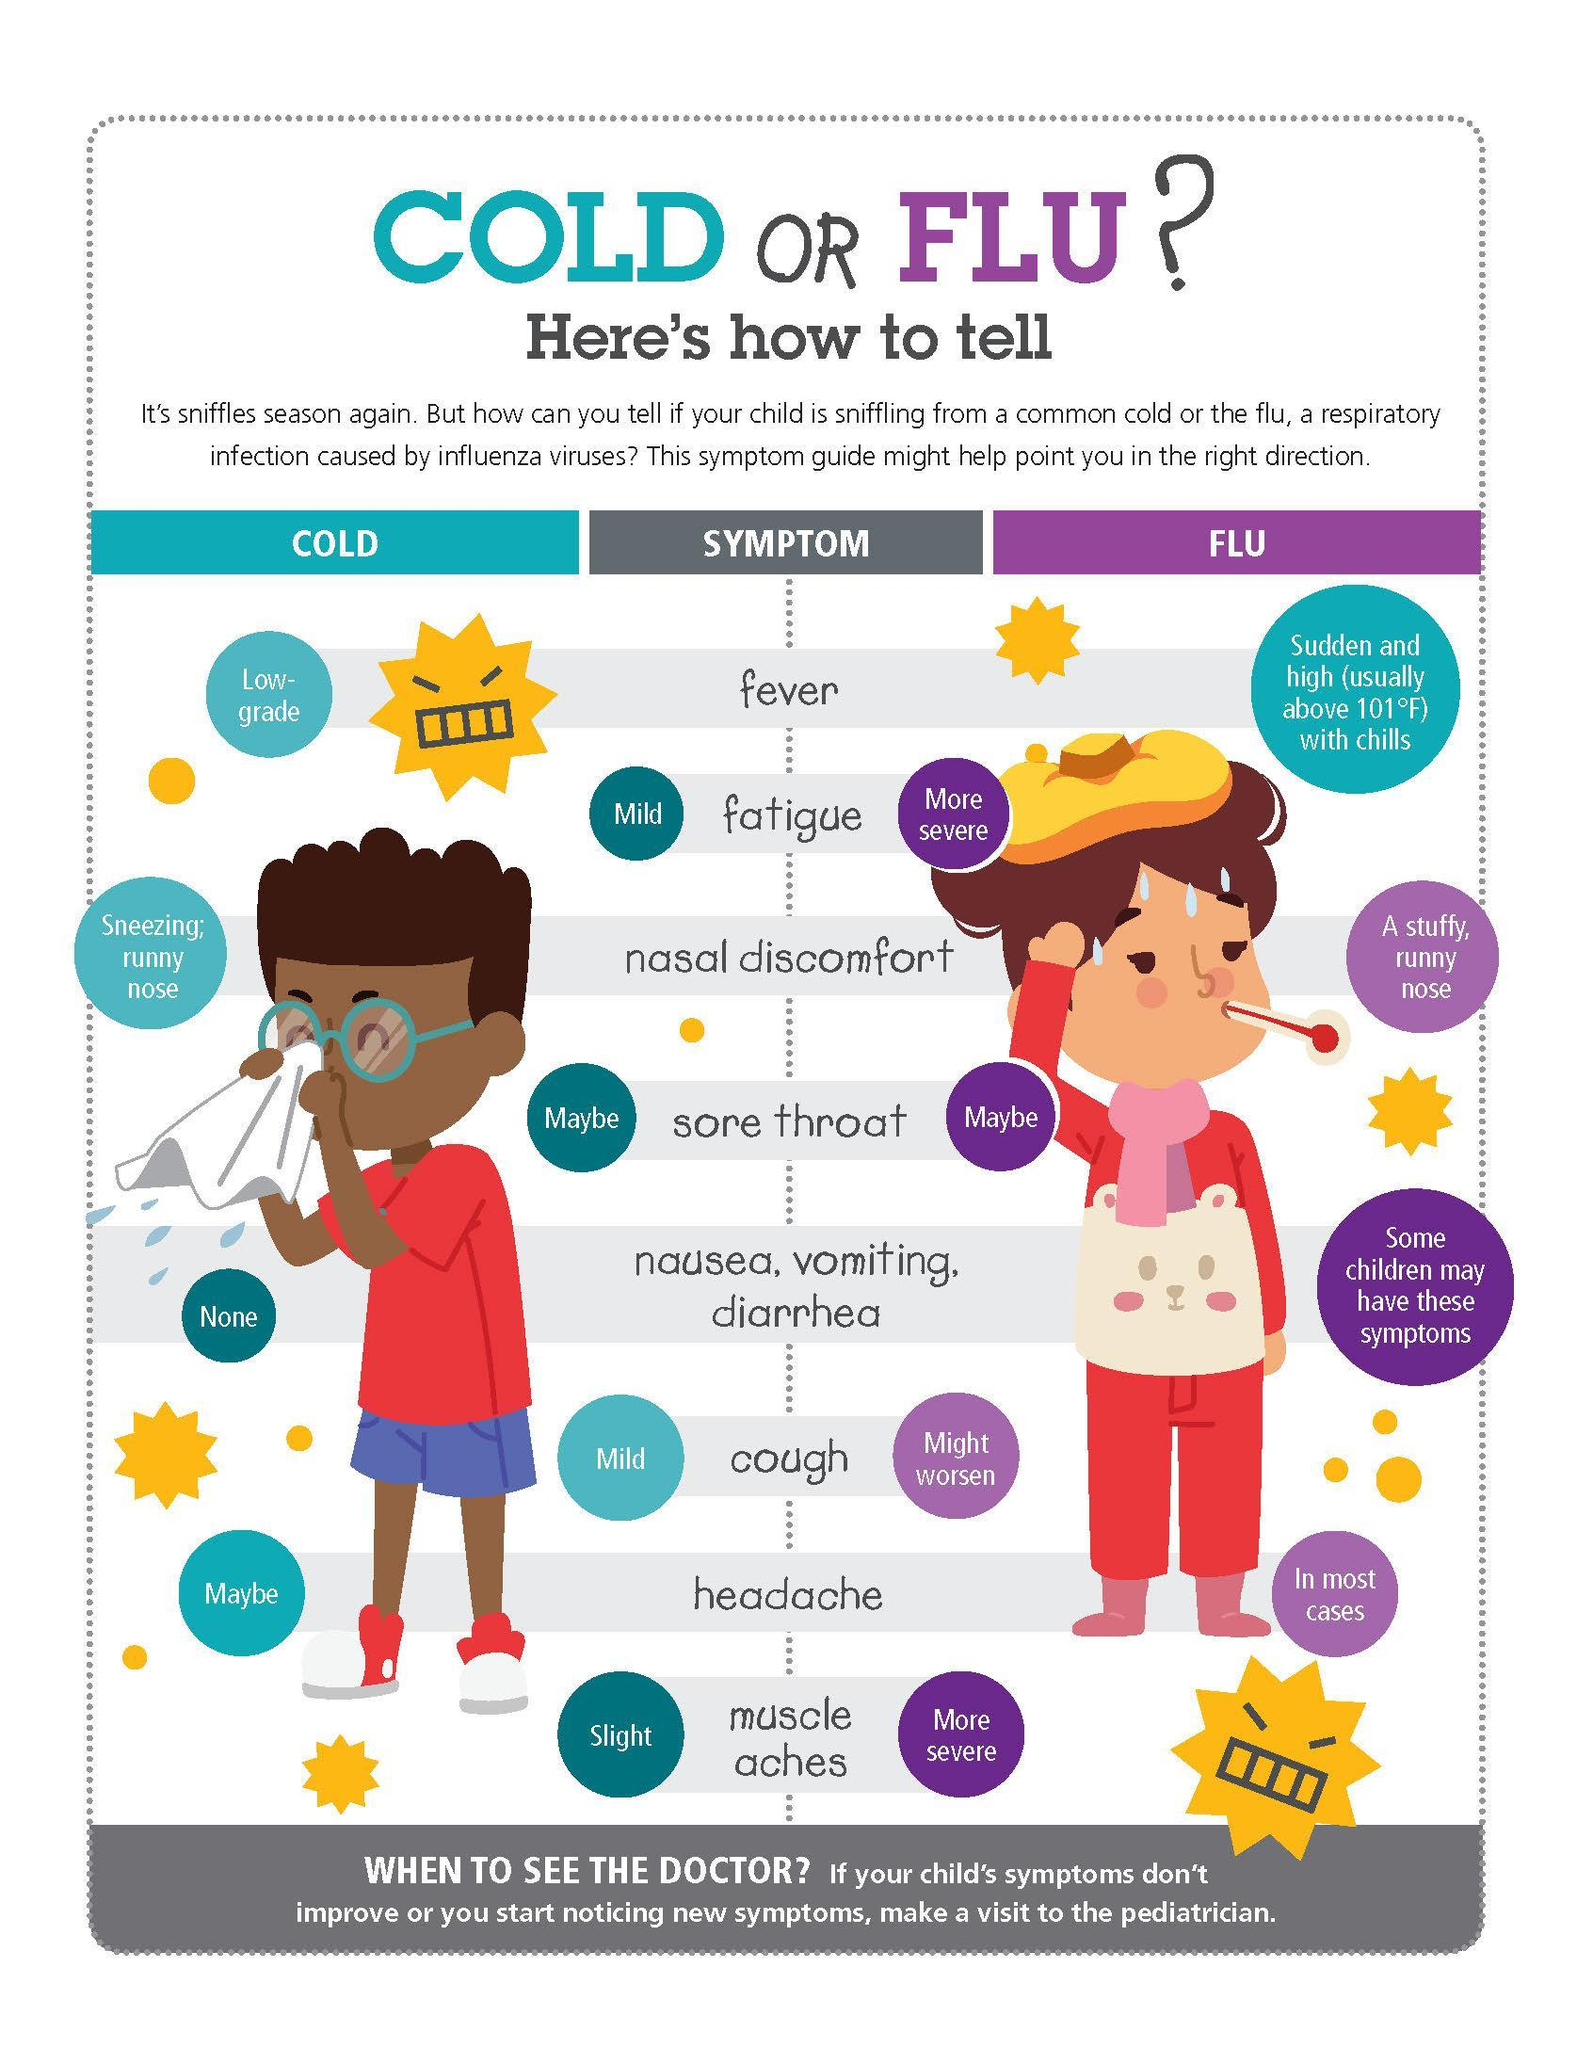How many symptoms of flu are more severe?
Answer the question with a short phrase. 2 Which symptoms of flu are more severe? fatigue, muscle aches How many mild symptoms are for cold? 2 Which symptoms of cold are mild? fatigue, cold 